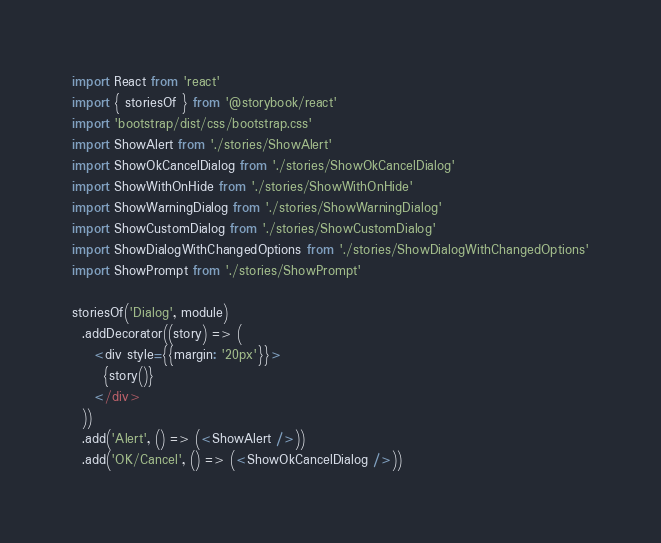<code> <loc_0><loc_0><loc_500><loc_500><_JavaScript_>import React from 'react'
import { storiesOf } from '@storybook/react'
import 'bootstrap/dist/css/bootstrap.css'
import ShowAlert from './stories/ShowAlert'
import ShowOkCancelDialog from './stories/ShowOkCancelDialog'
import ShowWithOnHide from './stories/ShowWithOnHide'
import ShowWarningDialog from './stories/ShowWarningDialog'
import ShowCustomDialog from './stories/ShowCustomDialog'
import ShowDialogWithChangedOptions from './stories/ShowDialogWithChangedOptions'
import ShowPrompt from './stories/ShowPrompt'

storiesOf('Dialog', module)
  .addDecorator((story) => (
    <div style={{margin: '20px'}}>
      {story()}
    </div>
  ))
  .add('Alert', () => (<ShowAlert />))
  .add('OK/Cancel', () => (<ShowOkCancelDialog />))</code> 